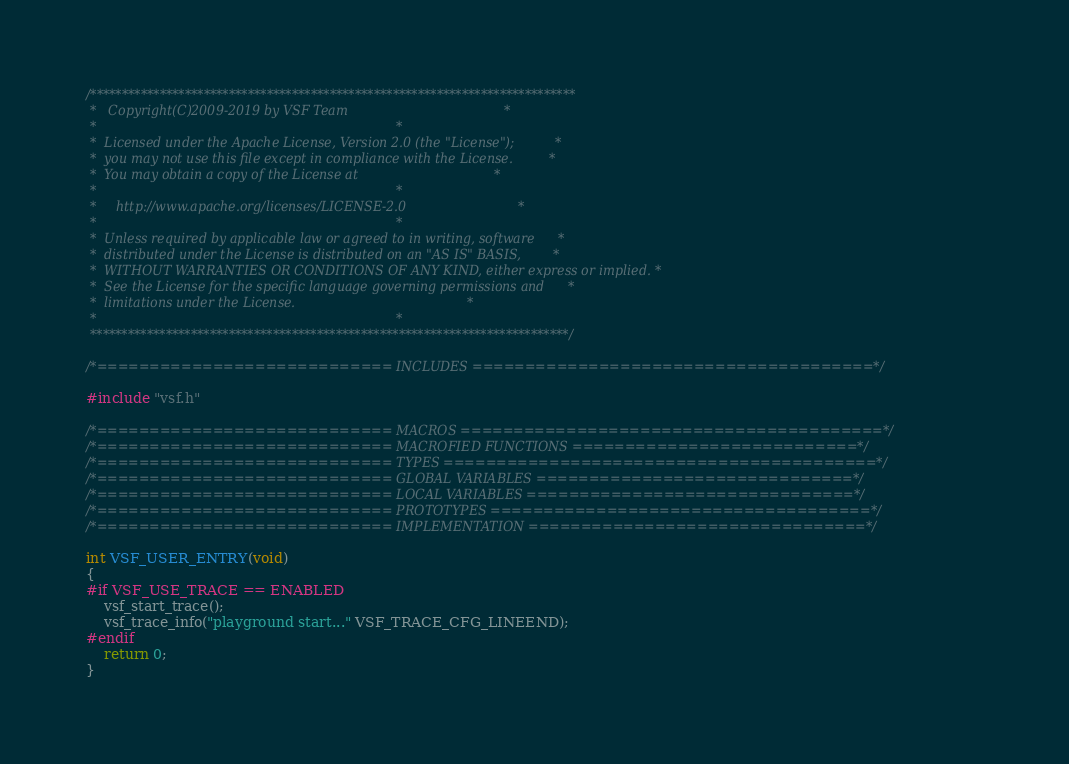<code> <loc_0><loc_0><loc_500><loc_500><_C_>/*****************************************************************************
 *   Copyright(C)2009-2019 by VSF Team                                       *
 *                                                                           *
 *  Licensed under the Apache License, Version 2.0 (the "License");          *
 *  you may not use this file except in compliance with the License.         *
 *  You may obtain a copy of the License at                                  *
 *                                                                           *
 *     http://www.apache.org/licenses/LICENSE-2.0                            *
 *                                                                           *
 *  Unless required by applicable law or agreed to in writing, software      *
 *  distributed under the License is distributed on an "AS IS" BASIS,        *
 *  WITHOUT WARRANTIES OR CONDITIONS OF ANY KIND, either express or implied. *
 *  See the License for the specific language governing permissions and      *
 *  limitations under the License.                                           *
 *                                                                           *
 ****************************************************************************/

/*============================ INCLUDES ======================================*/

#include "vsf.h"

/*============================ MACROS ========================================*/
/*============================ MACROFIED FUNCTIONS ===========================*/
/*============================ TYPES =========================================*/
/*============================ GLOBAL VARIABLES ==============================*/
/*============================ LOCAL VARIABLES ===============================*/
/*============================ PROTOTYPES ====================================*/
/*============================ IMPLEMENTATION ================================*/

int VSF_USER_ENTRY(void)
{
#if VSF_USE_TRACE == ENABLED
    vsf_start_trace();
    vsf_trace_info("playground start..." VSF_TRACE_CFG_LINEEND);
#endif
    return 0;
}
</code> 